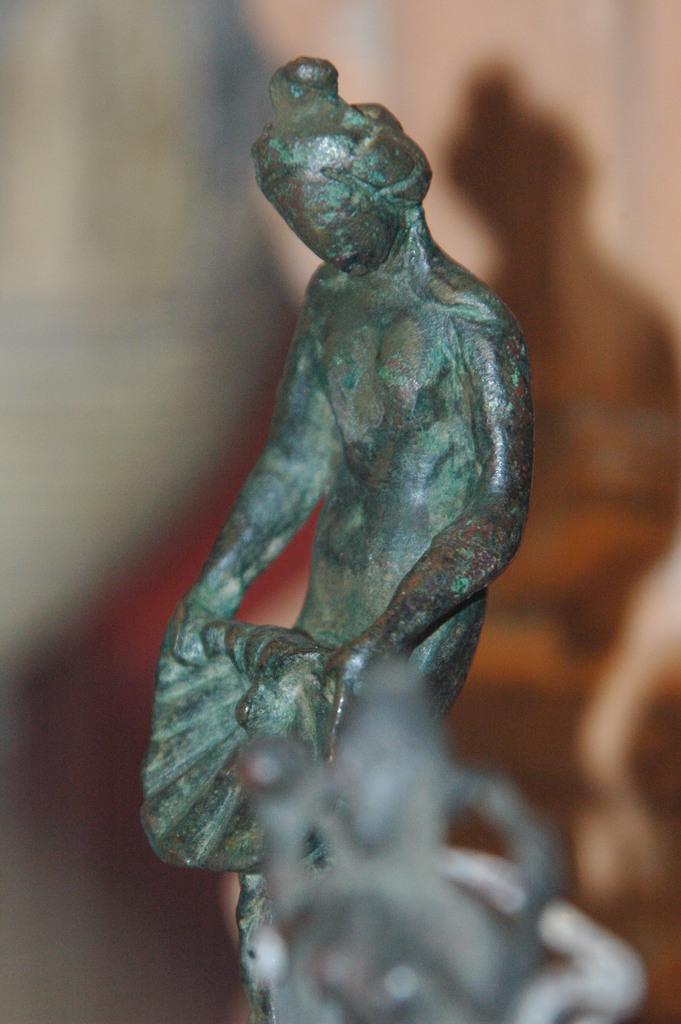Describe this image in one or two sentences. In this picture I see a thing in front which is blurred. In the middle of this picture I see a sculpture which is of green in color. 